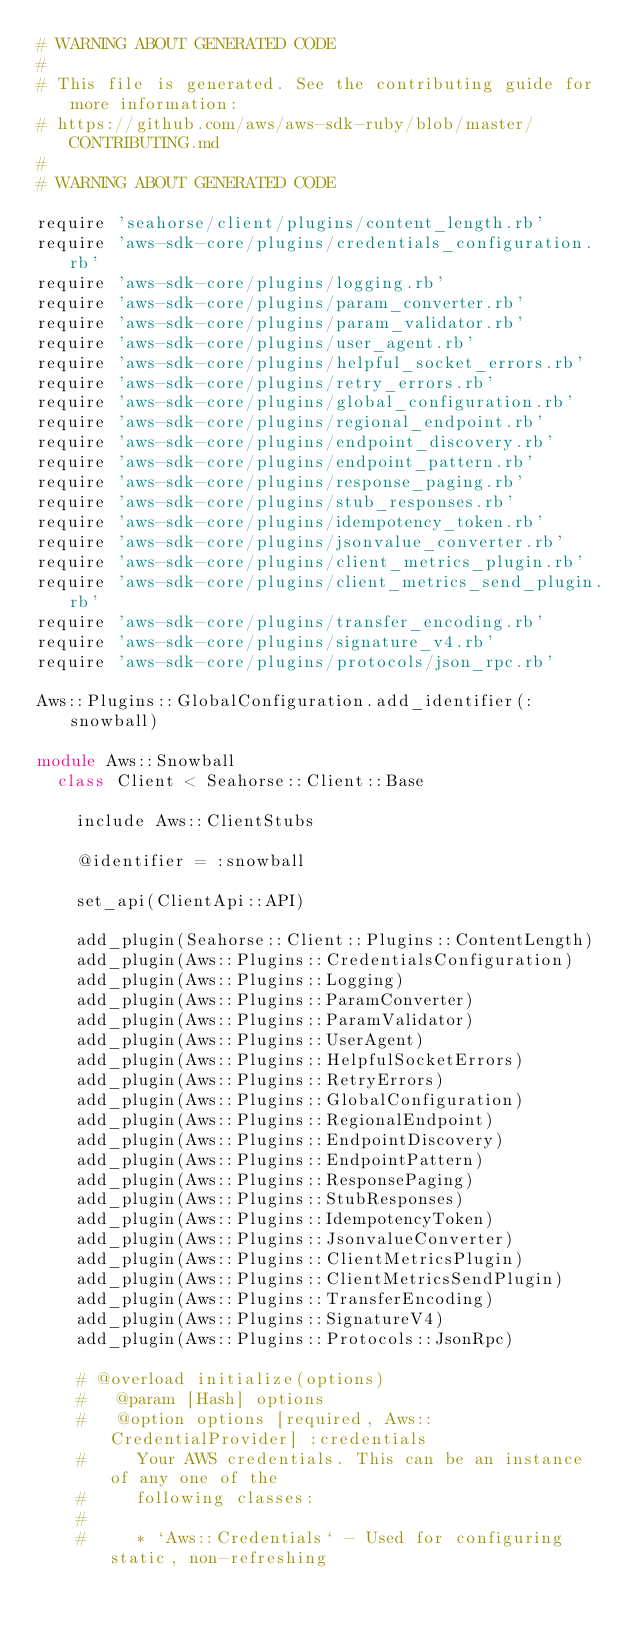<code> <loc_0><loc_0><loc_500><loc_500><_Ruby_># WARNING ABOUT GENERATED CODE
#
# This file is generated. See the contributing guide for more information:
# https://github.com/aws/aws-sdk-ruby/blob/master/CONTRIBUTING.md
#
# WARNING ABOUT GENERATED CODE

require 'seahorse/client/plugins/content_length.rb'
require 'aws-sdk-core/plugins/credentials_configuration.rb'
require 'aws-sdk-core/plugins/logging.rb'
require 'aws-sdk-core/plugins/param_converter.rb'
require 'aws-sdk-core/plugins/param_validator.rb'
require 'aws-sdk-core/plugins/user_agent.rb'
require 'aws-sdk-core/plugins/helpful_socket_errors.rb'
require 'aws-sdk-core/plugins/retry_errors.rb'
require 'aws-sdk-core/plugins/global_configuration.rb'
require 'aws-sdk-core/plugins/regional_endpoint.rb'
require 'aws-sdk-core/plugins/endpoint_discovery.rb'
require 'aws-sdk-core/plugins/endpoint_pattern.rb'
require 'aws-sdk-core/plugins/response_paging.rb'
require 'aws-sdk-core/plugins/stub_responses.rb'
require 'aws-sdk-core/plugins/idempotency_token.rb'
require 'aws-sdk-core/plugins/jsonvalue_converter.rb'
require 'aws-sdk-core/plugins/client_metrics_plugin.rb'
require 'aws-sdk-core/plugins/client_metrics_send_plugin.rb'
require 'aws-sdk-core/plugins/transfer_encoding.rb'
require 'aws-sdk-core/plugins/signature_v4.rb'
require 'aws-sdk-core/plugins/protocols/json_rpc.rb'

Aws::Plugins::GlobalConfiguration.add_identifier(:snowball)

module Aws::Snowball
  class Client < Seahorse::Client::Base

    include Aws::ClientStubs

    @identifier = :snowball

    set_api(ClientApi::API)

    add_plugin(Seahorse::Client::Plugins::ContentLength)
    add_plugin(Aws::Plugins::CredentialsConfiguration)
    add_plugin(Aws::Plugins::Logging)
    add_plugin(Aws::Plugins::ParamConverter)
    add_plugin(Aws::Plugins::ParamValidator)
    add_plugin(Aws::Plugins::UserAgent)
    add_plugin(Aws::Plugins::HelpfulSocketErrors)
    add_plugin(Aws::Plugins::RetryErrors)
    add_plugin(Aws::Plugins::GlobalConfiguration)
    add_plugin(Aws::Plugins::RegionalEndpoint)
    add_plugin(Aws::Plugins::EndpointDiscovery)
    add_plugin(Aws::Plugins::EndpointPattern)
    add_plugin(Aws::Plugins::ResponsePaging)
    add_plugin(Aws::Plugins::StubResponses)
    add_plugin(Aws::Plugins::IdempotencyToken)
    add_plugin(Aws::Plugins::JsonvalueConverter)
    add_plugin(Aws::Plugins::ClientMetricsPlugin)
    add_plugin(Aws::Plugins::ClientMetricsSendPlugin)
    add_plugin(Aws::Plugins::TransferEncoding)
    add_plugin(Aws::Plugins::SignatureV4)
    add_plugin(Aws::Plugins::Protocols::JsonRpc)

    # @overload initialize(options)
    #   @param [Hash] options
    #   @option options [required, Aws::CredentialProvider] :credentials
    #     Your AWS credentials. This can be an instance of any one of the
    #     following classes:
    #
    #     * `Aws::Credentials` - Used for configuring static, non-refreshing</code> 